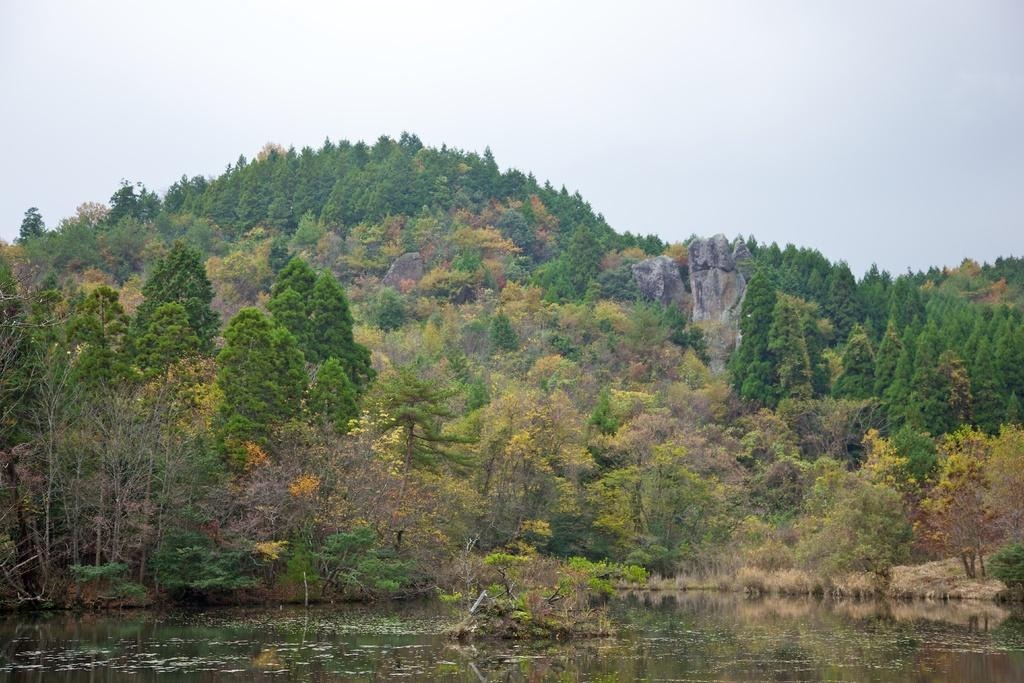What type of landscape is depicted in the image? The image features hills, trees, and plants, suggesting a natural landscape. What can be seen in the image besides the landscape? There is water visible in the image, as well as the sky. Can you describe the vegetation in the image? The image includes trees and plants. What is the condition of the sky in the image? The sky is visible in the image. What type of hall can be seen in the image? There is no hall present in the image; it features a natural landscape with hills, trees, plants, water, and the sky. What question is being asked in the image? There is no question being asked in the image; it is a visual representation of a landscape. 